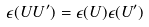Convert formula to latex. <formula><loc_0><loc_0><loc_500><loc_500>\epsilon ( U U ^ { \prime } ) = \epsilon ( U ) \epsilon ( U ^ { \prime } )</formula> 